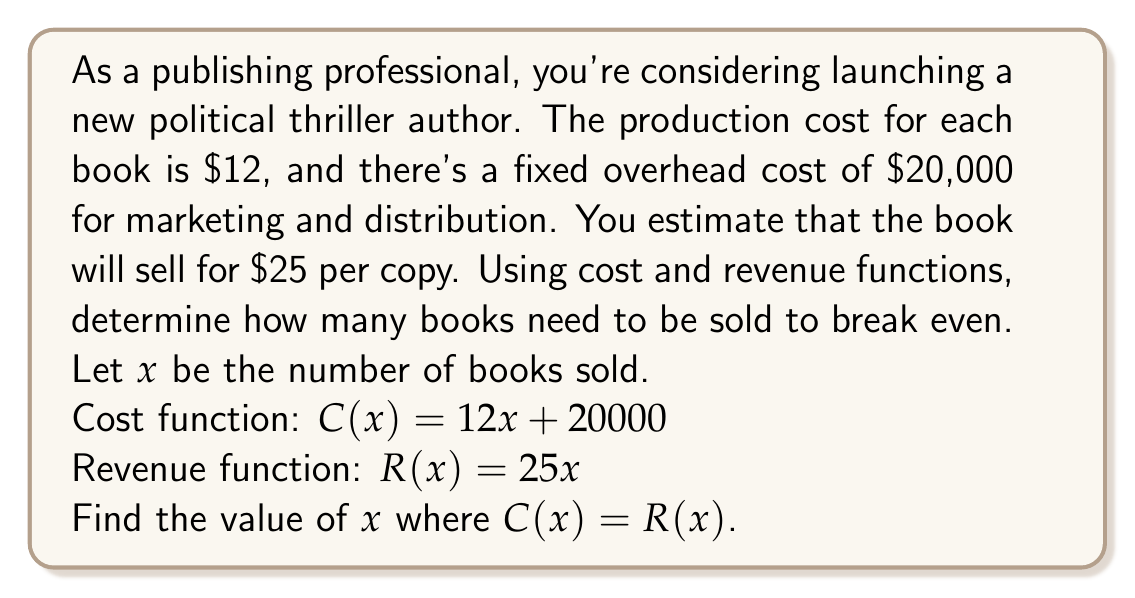Provide a solution to this math problem. To find the breakeven point, we need to set the cost function equal to the revenue function and solve for $x$:

$$C(x) = R(x)$$
$$12x + 20000 = 25x$$

Now, let's solve this equation step by step:

1) Subtract $12x$ from both sides:
   $$20000 = 13x$$

2) Divide both sides by 13:
   $$\frac{20000}{13} = x$$

3) Calculate the result:
   $$x \approx 1538.46$$

Since we can't sell a fractional number of books, we need to round up to the nearest whole number.

Therefore, the publisher needs to sell 1,539 books to break even.

To verify:
Cost at 1,539 books: $C(1539) = 12(1539) + 20000 = 38468$
Revenue at 1,539 books: $R(1539) = 25(1539) = 38475$

As we can see, the revenue slightly exceeds the cost at 1,539 books, confirming our breakeven point.
Answer: 1,539 books 